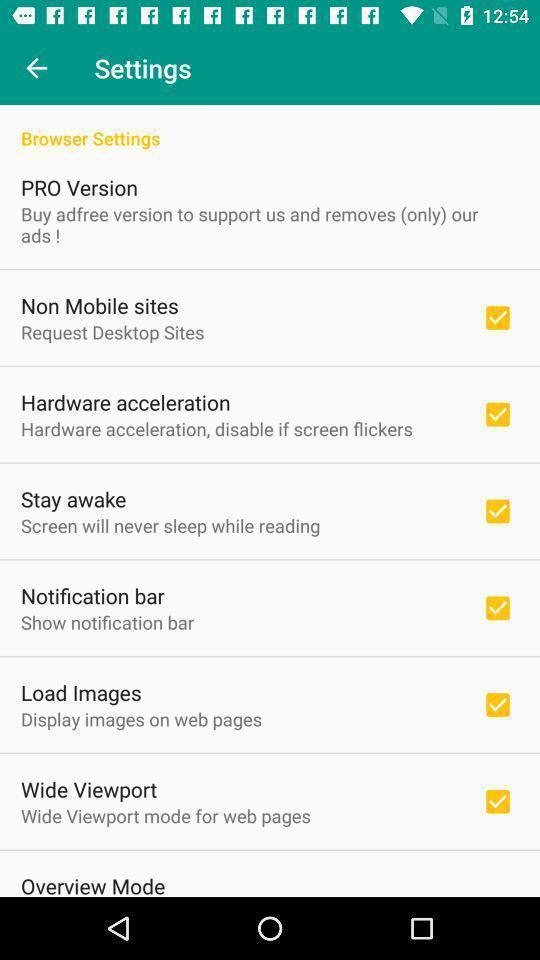Provide a description of this screenshot. Settings page displaying. 